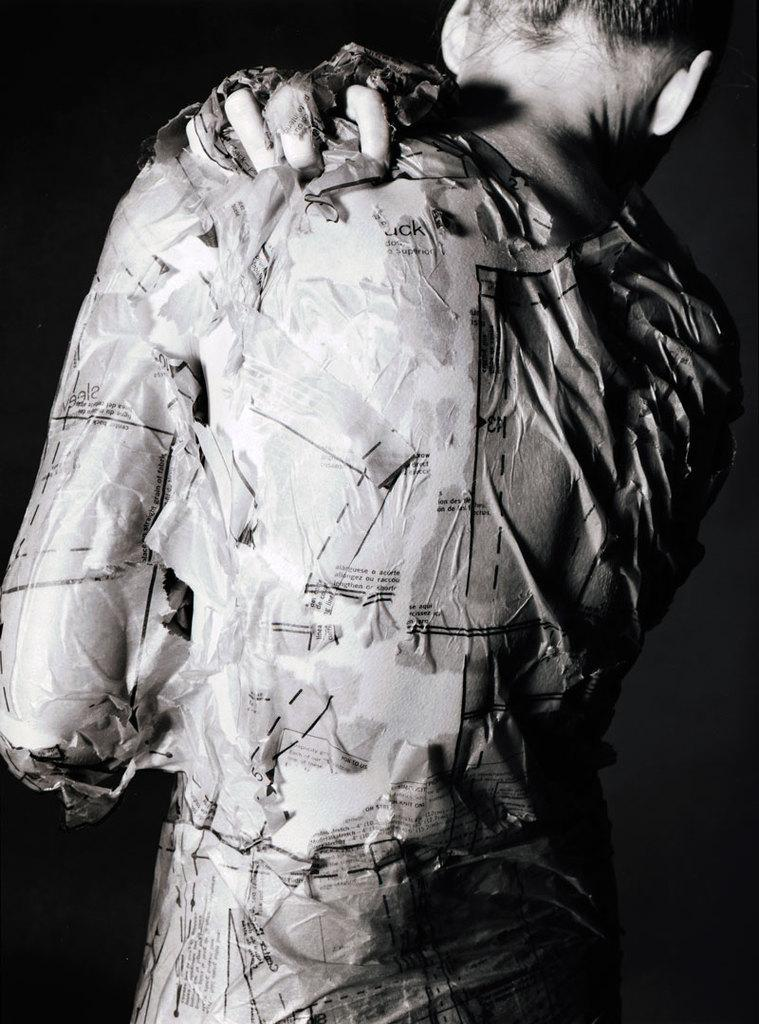What is the main subject of the image? There is a person standing in the image. What is on the person in the image? The person has paper pieces on them. What is the color of the background in the image? The background in the image is black. Can you see a cat sitting on the person's shoulder in the image? No, there is no cat present in the image. What type of owl can be seen in the image? There is no owl present in the image. 